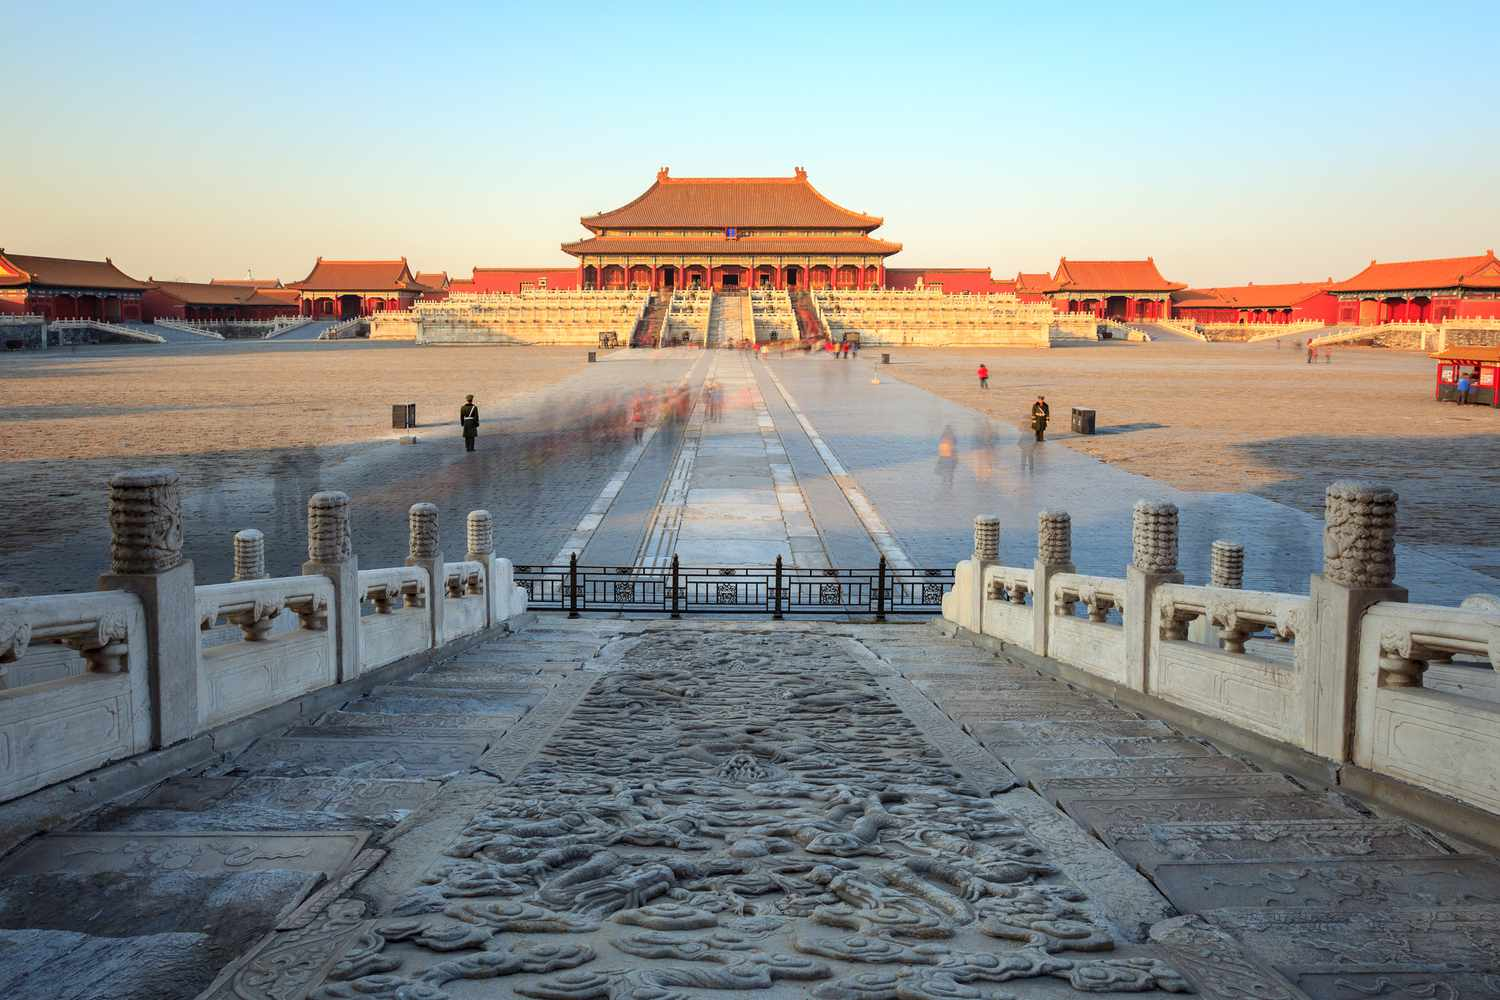If you could imagine this place come to life, what story would it tell? In a world where the ancient stone carvings and wooden structures of the Forbidden City could speak, they would weave tales of regal ceremonies and imperial edicts that shaped dynasties. Imagine the Hall of Supreme Harmony bustling with lavish processions, silk-clad officials bowing respectfully to the emperor seated on the Dragon Throne. At dawn, as the first light bathed the golden rooftops, the city would whisper stories of the Ming architects painstakingly crafting each detail. Under the starlit sky, the walls would murmur about spies skirting the shadows and the midnight oil burning in the emperor's study. The stone lions standing guard at the entrance would recount centuries of visitors, from humble servants to foreign dignitaries, each leaving an indelible mark on the palace's legacy. 